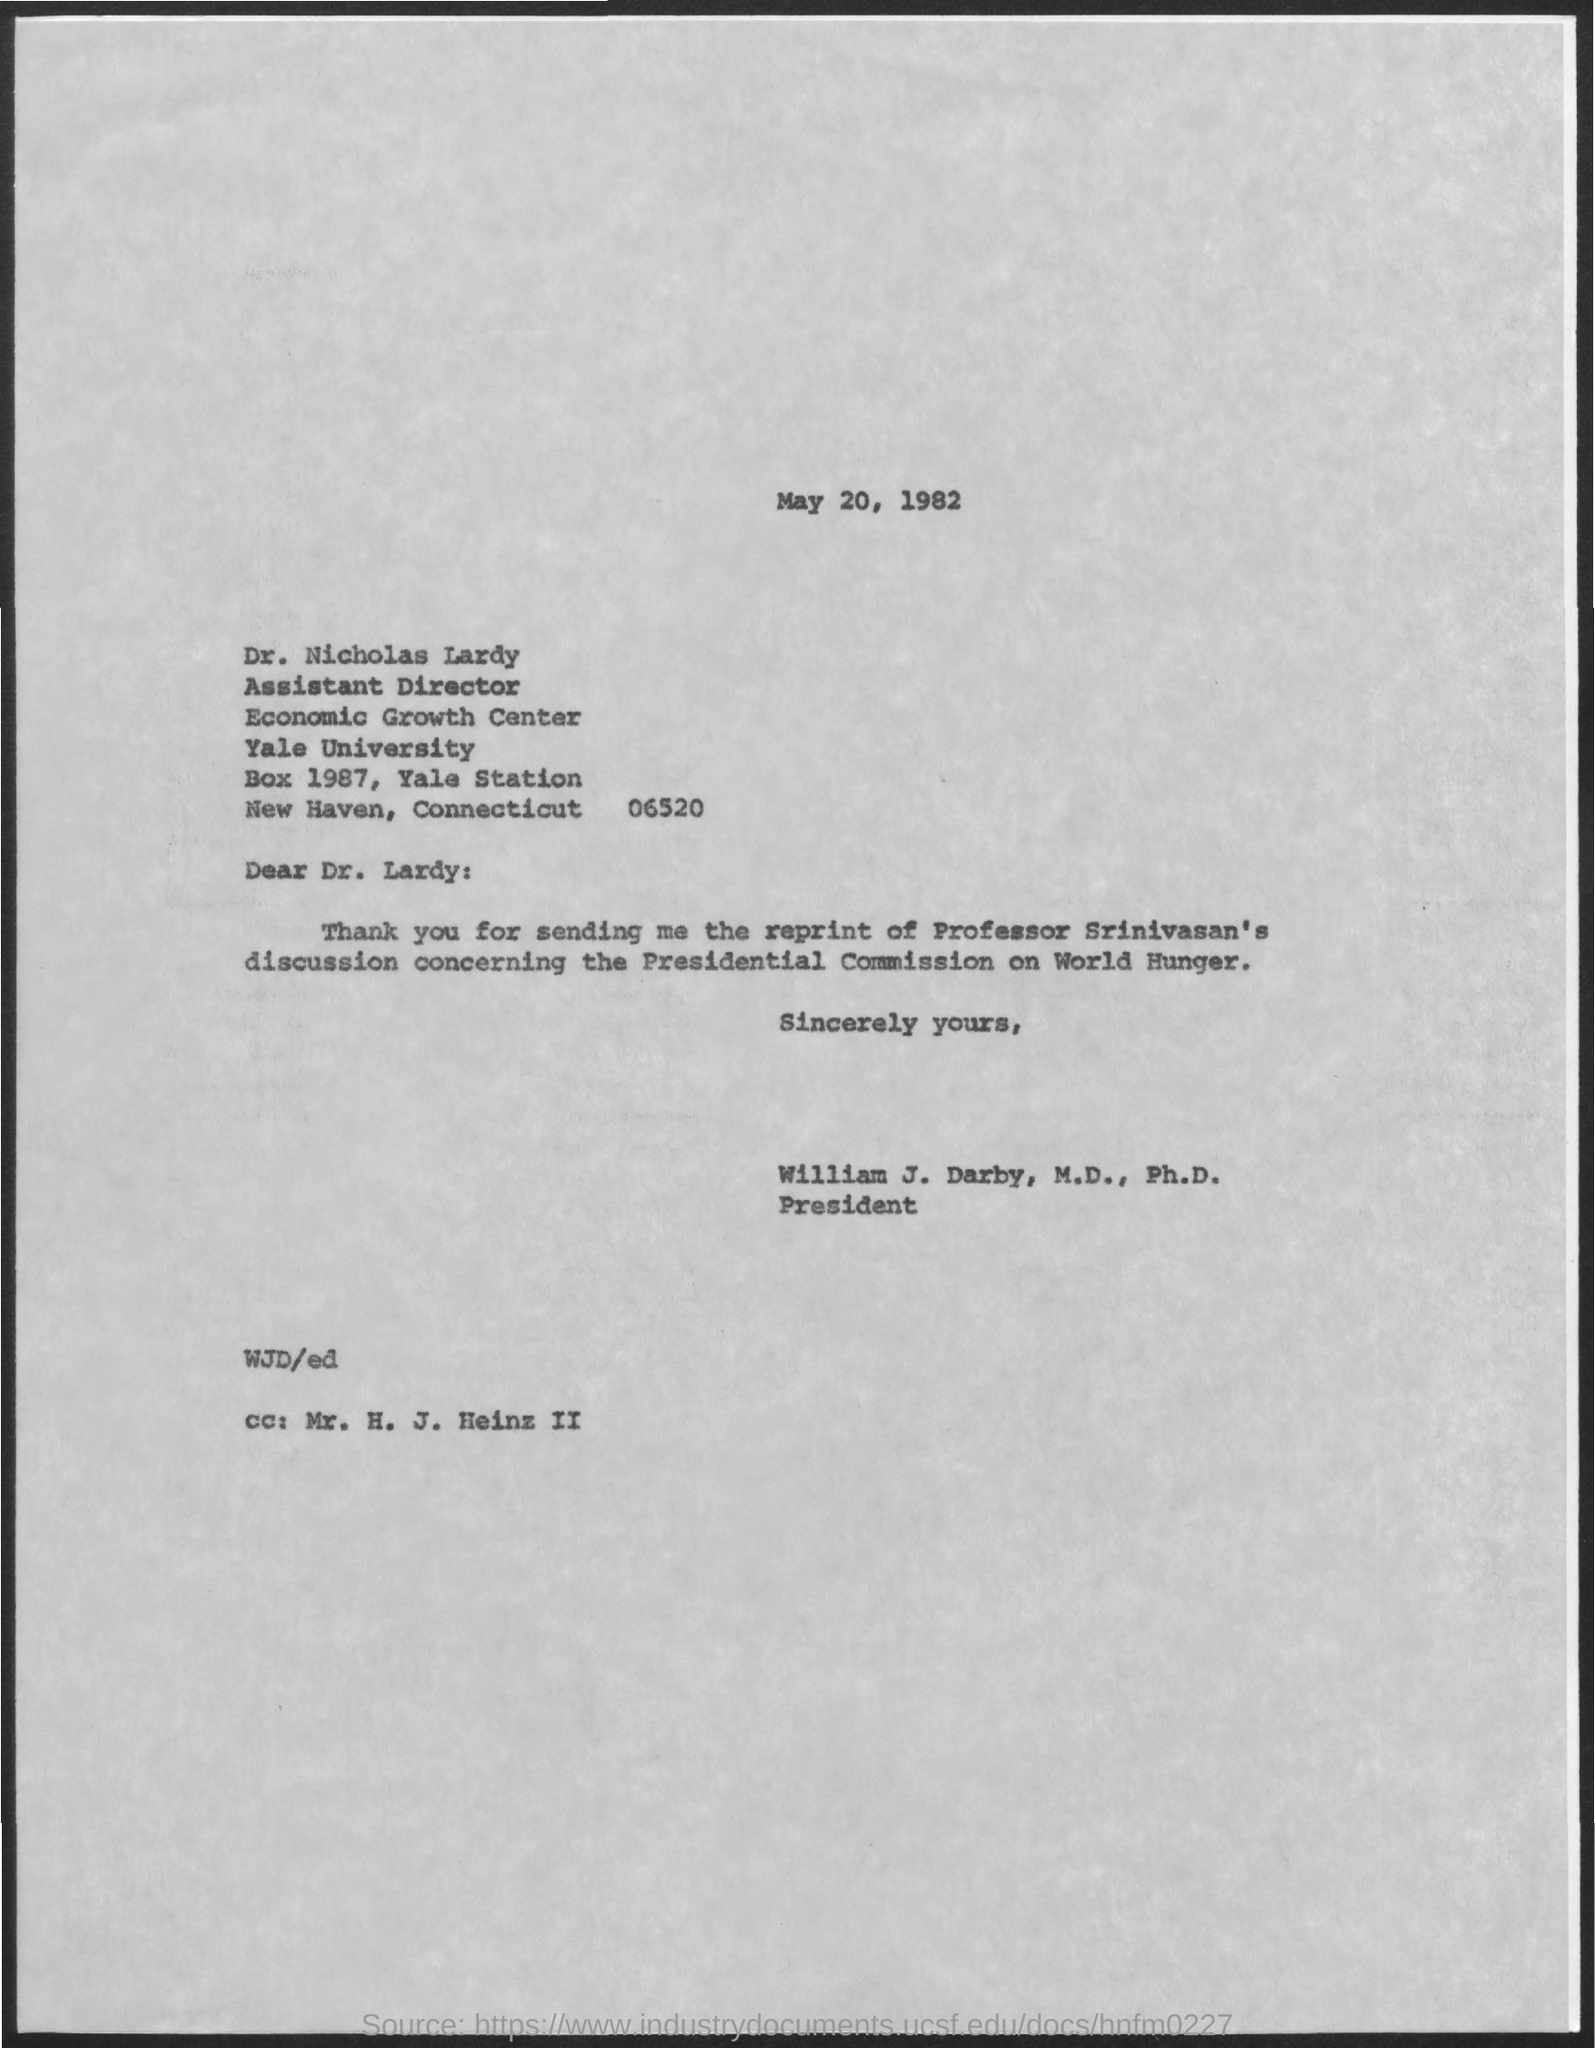What is the date on the document?
Give a very brief answer. May 20, 1982. To Whom is this letter addressed to?
Offer a terse response. Dr. nicholas lardy. What did Dr. Lardy send?
Ensure brevity in your answer.  Reprint of professor srinivasan's discussion. Discussion concerning what?
Ensure brevity in your answer.  The presidential commission on world hunger. Who is the cc: addressed to?
Ensure brevity in your answer.  Mr. H. J. Heinz II. 